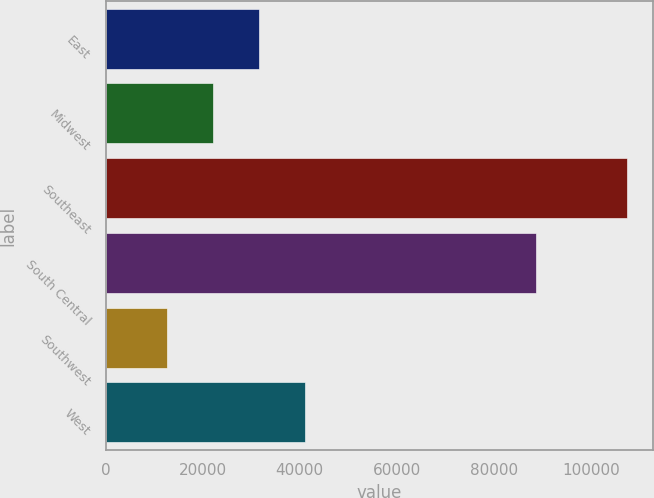Convert chart to OTSL. <chart><loc_0><loc_0><loc_500><loc_500><bar_chart><fcel>East<fcel>Midwest<fcel>Southeast<fcel>South Central<fcel>Southwest<fcel>West<nl><fcel>31580<fcel>22090<fcel>107500<fcel>88600<fcel>12600<fcel>41070<nl></chart> 